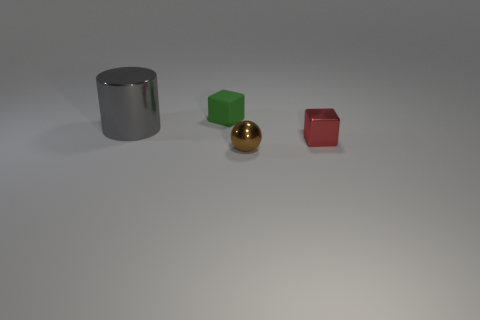Add 1 green matte things. How many objects exist? 5 Subtract all green blocks. How many blocks are left? 1 Subtract all green cylinders. Subtract all purple spheres. How many cylinders are left? 1 Subtract all small metal things. Subtract all large gray matte blocks. How many objects are left? 2 Add 1 gray metal things. How many gray metal things are left? 2 Add 1 green metallic cubes. How many green metallic cubes exist? 1 Subtract 0 brown cylinders. How many objects are left? 4 Subtract all spheres. How many objects are left? 3 